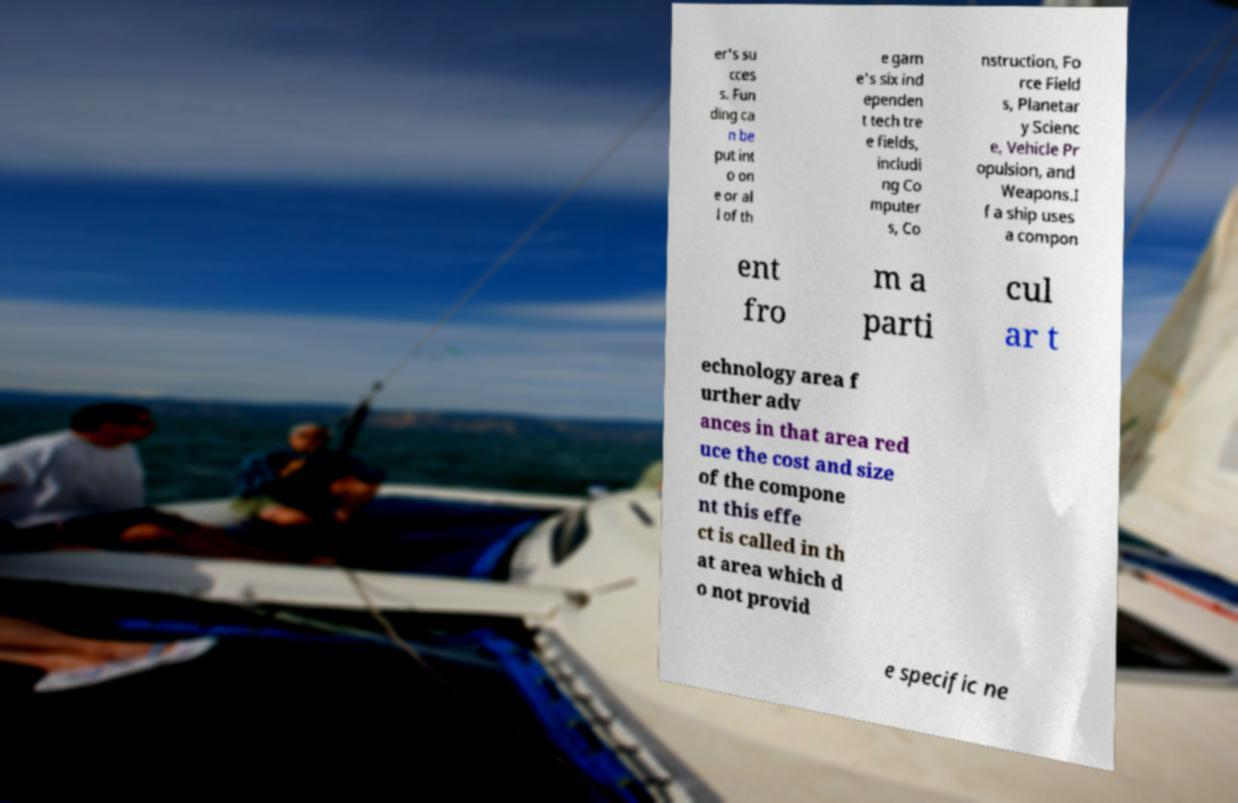There's text embedded in this image that I need extracted. Can you transcribe it verbatim? er's su cces s. Fun ding ca n be put int o on e or al l of th e gam e's six ind ependen t tech tre e fields, includi ng Co mputer s, Co nstruction, Fo rce Field s, Planetar y Scienc e, Vehicle Pr opulsion, and Weapons.I f a ship uses a compon ent fro m a parti cul ar t echnology area f urther adv ances in that area red uce the cost and size of the compone nt this effe ct is called in th at area which d o not provid e specific ne 